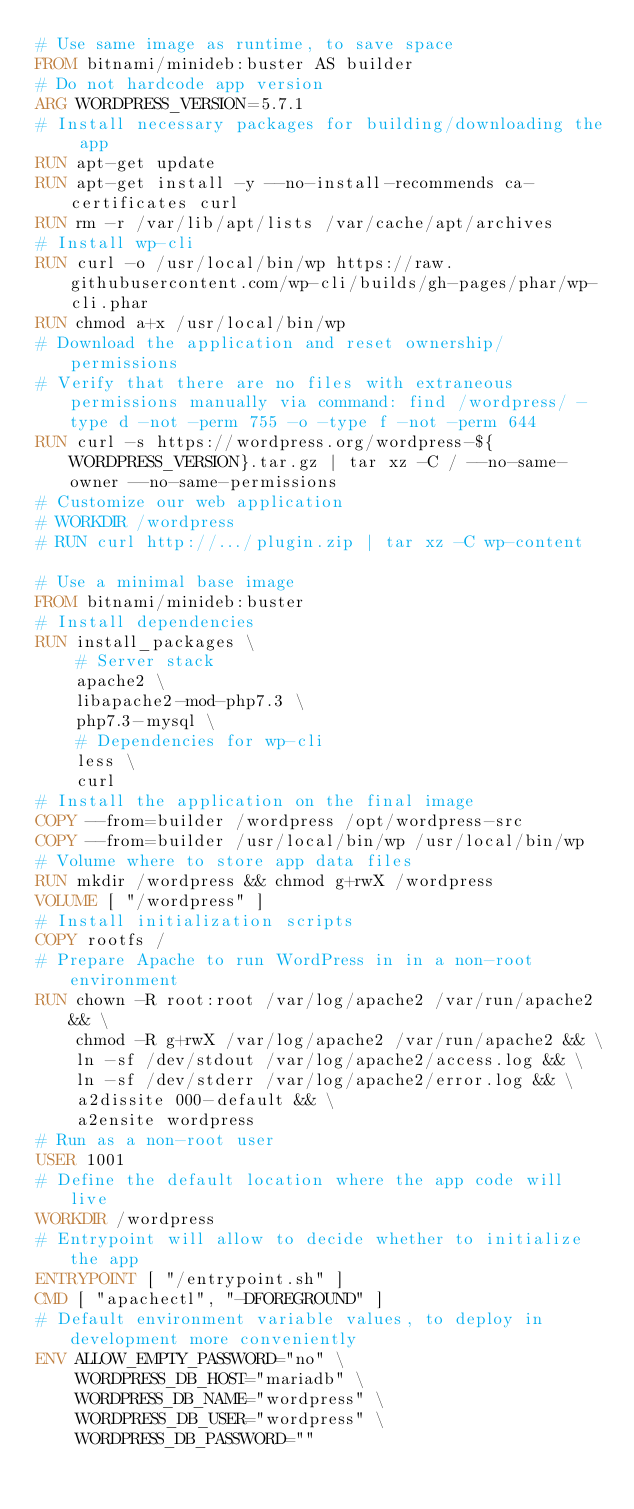<code> <loc_0><loc_0><loc_500><loc_500><_Dockerfile_># Use same image as runtime, to save space
FROM bitnami/minideb:buster AS builder
# Do not hardcode app version
ARG WORDPRESS_VERSION=5.7.1
# Install necessary packages for building/downloading the app
RUN apt-get update
RUN apt-get install -y --no-install-recommends ca-certificates curl
RUN rm -r /var/lib/apt/lists /var/cache/apt/archives
# Install wp-cli
RUN curl -o /usr/local/bin/wp https://raw.githubusercontent.com/wp-cli/builds/gh-pages/phar/wp-cli.phar
RUN chmod a+x /usr/local/bin/wp
# Download the application and reset ownership/permissions
# Verify that there are no files with extraneous permissions manually via command: find /wordpress/ -type d -not -perm 755 -o -type f -not -perm 644
RUN curl -s https://wordpress.org/wordpress-${WORDPRESS_VERSION}.tar.gz | tar xz -C / --no-same-owner --no-same-permissions
# Customize our web application
# WORKDIR /wordpress
# RUN curl http://.../plugin.zip | tar xz -C wp-content

# Use a minimal base image
FROM bitnami/minideb:buster
# Install dependencies
RUN install_packages \
    # Server stack
    apache2 \
    libapache2-mod-php7.3 \
    php7.3-mysql \
    # Dependencies for wp-cli
    less \
    curl
# Install the application on the final image
COPY --from=builder /wordpress /opt/wordpress-src
COPY --from=builder /usr/local/bin/wp /usr/local/bin/wp
# Volume where to store app data files
RUN mkdir /wordpress && chmod g+rwX /wordpress
VOLUME [ "/wordpress" ]
# Install initialization scripts
COPY rootfs /
# Prepare Apache to run WordPress in in a non-root environment
RUN chown -R root:root /var/log/apache2 /var/run/apache2 && \
    chmod -R g+rwX /var/log/apache2 /var/run/apache2 && \
    ln -sf /dev/stdout /var/log/apache2/access.log && \
    ln -sf /dev/stderr /var/log/apache2/error.log && \
    a2dissite 000-default && \
    a2ensite wordpress
# Run as a non-root user
USER 1001
# Define the default location where the app code will live
WORKDIR /wordpress
# Entrypoint will allow to decide whether to initialize the app
ENTRYPOINT [ "/entrypoint.sh" ]
CMD [ "apachectl", "-DFOREGROUND" ]
# Default environment variable values, to deploy in development more conveniently
ENV ALLOW_EMPTY_PASSWORD="no" \
    WORDPRESS_DB_HOST="mariadb" \
    WORDPRESS_DB_NAME="wordpress" \
    WORDPRESS_DB_USER="wordpress" \
    WORDPRESS_DB_PASSWORD=""
</code> 